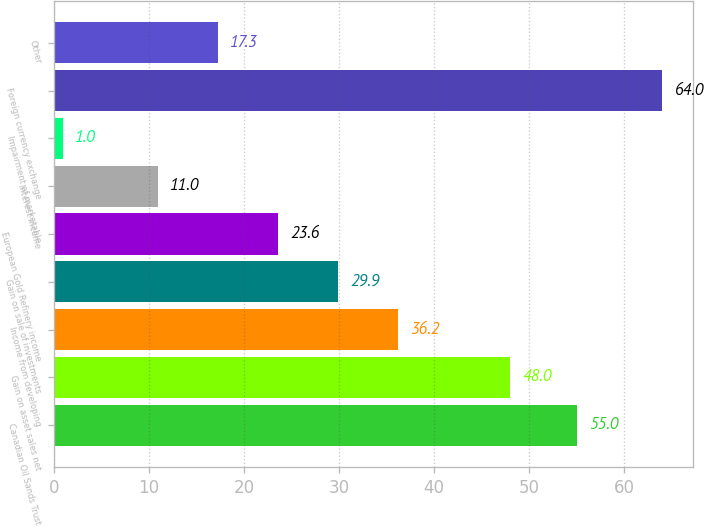Convert chart to OTSL. <chart><loc_0><loc_0><loc_500><loc_500><bar_chart><fcel>Canadian Oil Sands Trust<fcel>Gain on asset sales net<fcel>Income from developing<fcel>Gain on sale of investments<fcel>European Gold Refinery income<fcel>Interest income<fcel>Impairment of marketable<fcel>Foreign currency exchange<fcel>Other<nl><fcel>55<fcel>48<fcel>36.2<fcel>29.9<fcel>23.6<fcel>11<fcel>1<fcel>64<fcel>17.3<nl></chart> 